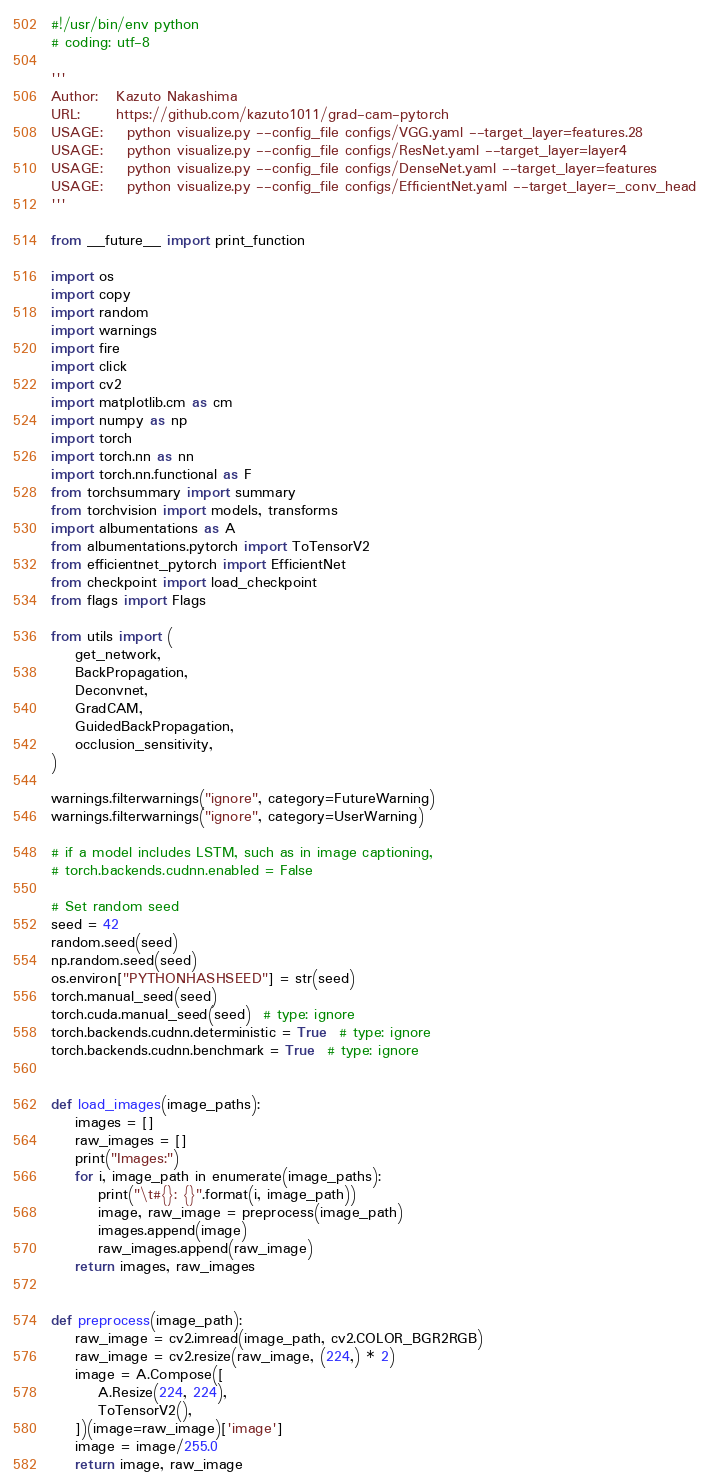<code> <loc_0><loc_0><loc_500><loc_500><_Python_>#!/usr/bin/env python
# coding: utf-8

'''
Author:   Kazuto Nakashima
URL:      https://github.com/kazuto1011/grad-cam-pytorch
USAGE:    python visualize.py --config_file configs/VGG.yaml --target_layer=features.28
USAGE:    python visualize.py --config_file configs/ResNet.yaml --target_layer=layer4
USAGE:    python visualize.py --config_file configs/DenseNet.yaml --target_layer=features
USAGE:    python visualize.py --config_file configs/EfficientNet.yaml --target_layer=_conv_head
'''

from __future__ import print_function

import os
import copy
import random
import warnings
import fire
import click
import cv2
import matplotlib.cm as cm
import numpy as np
import torch
import torch.nn as nn
import torch.nn.functional as F
from torchsummary import summary
from torchvision import models, transforms
import albumentations as A
from albumentations.pytorch import ToTensorV2
from efficientnet_pytorch import EfficientNet
from checkpoint import load_checkpoint
from flags import Flags

from utils import (
    get_network,
    BackPropagation,
    Deconvnet,
    GradCAM,
    GuidedBackPropagation,
    occlusion_sensitivity,
)

warnings.filterwarnings("ignore", category=FutureWarning)
warnings.filterwarnings("ignore", category=UserWarning)

# if a model includes LSTM, such as in image captioning,
# torch.backends.cudnn.enabled = False

# Set random seed
seed = 42
random.seed(seed)
np.random.seed(seed)
os.environ["PYTHONHASHSEED"] = str(seed)
torch.manual_seed(seed)
torch.cuda.manual_seed(seed)  # type: ignore
torch.backends.cudnn.deterministic = True  # type: ignore
torch.backends.cudnn.benchmark = True  # type: ignore


def load_images(image_paths):
    images = []
    raw_images = []
    print("Images:")
    for i, image_path in enumerate(image_paths):
        print("\t#{}: {}".format(i, image_path))
        image, raw_image = preprocess(image_path)
        images.append(image)
        raw_images.append(raw_image)
    return images, raw_images


def preprocess(image_path):
    raw_image = cv2.imread(image_path, cv2.COLOR_BGR2RGB)
    raw_image = cv2.resize(raw_image, (224,) * 2)
    image = A.Compose([
        A.Resize(224, 224),
        ToTensorV2(),
    ])(image=raw_image)['image']
    image = image/255.0
    return image, raw_image

</code> 